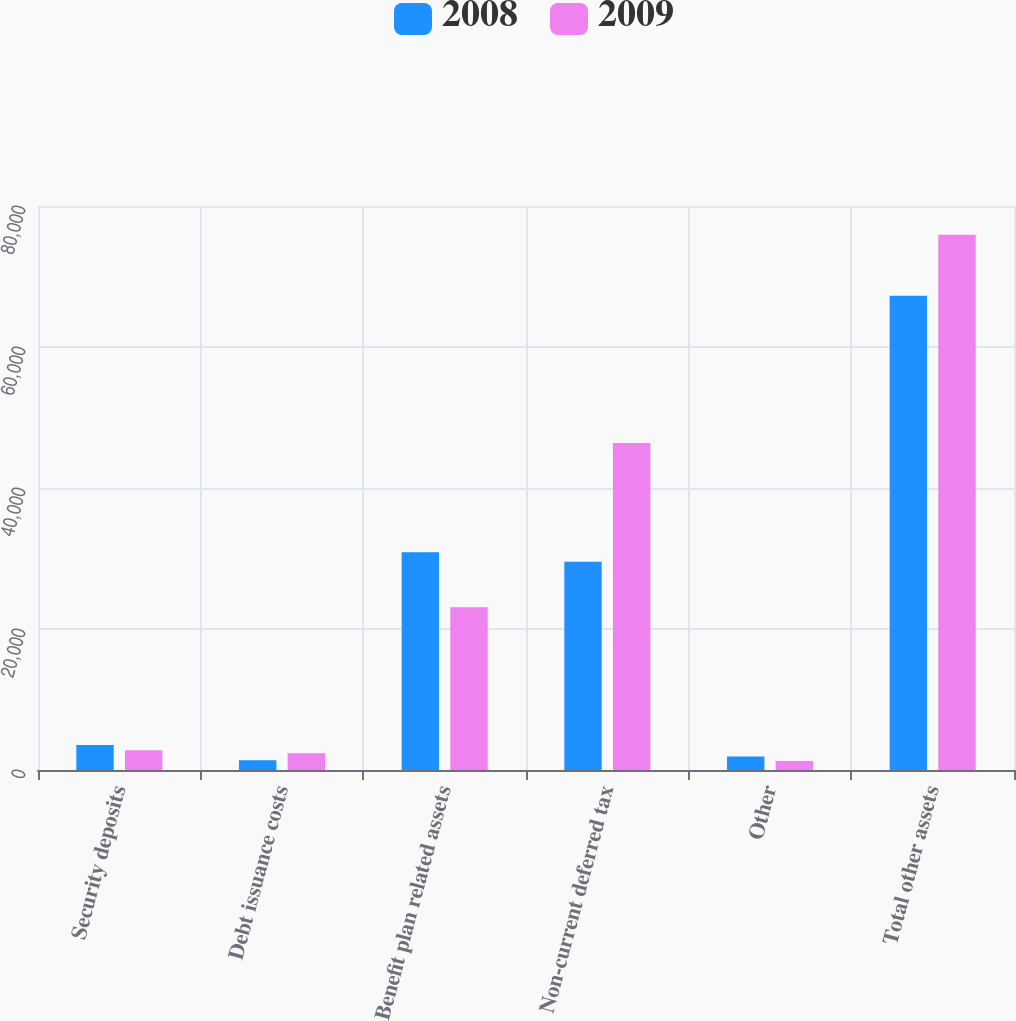Convert chart to OTSL. <chart><loc_0><loc_0><loc_500><loc_500><stacked_bar_chart><ecel><fcel>Security deposits<fcel>Debt issuance costs<fcel>Benefit plan related assets<fcel>Non-current deferred tax<fcel>Other<fcel>Total other assets<nl><fcel>2008<fcel>3545<fcel>1384<fcel>30903<fcel>29527<fcel>1904<fcel>67263<nl><fcel>2009<fcel>2796<fcel>2376<fcel>23095<fcel>46378<fcel>1275<fcel>75920<nl></chart> 